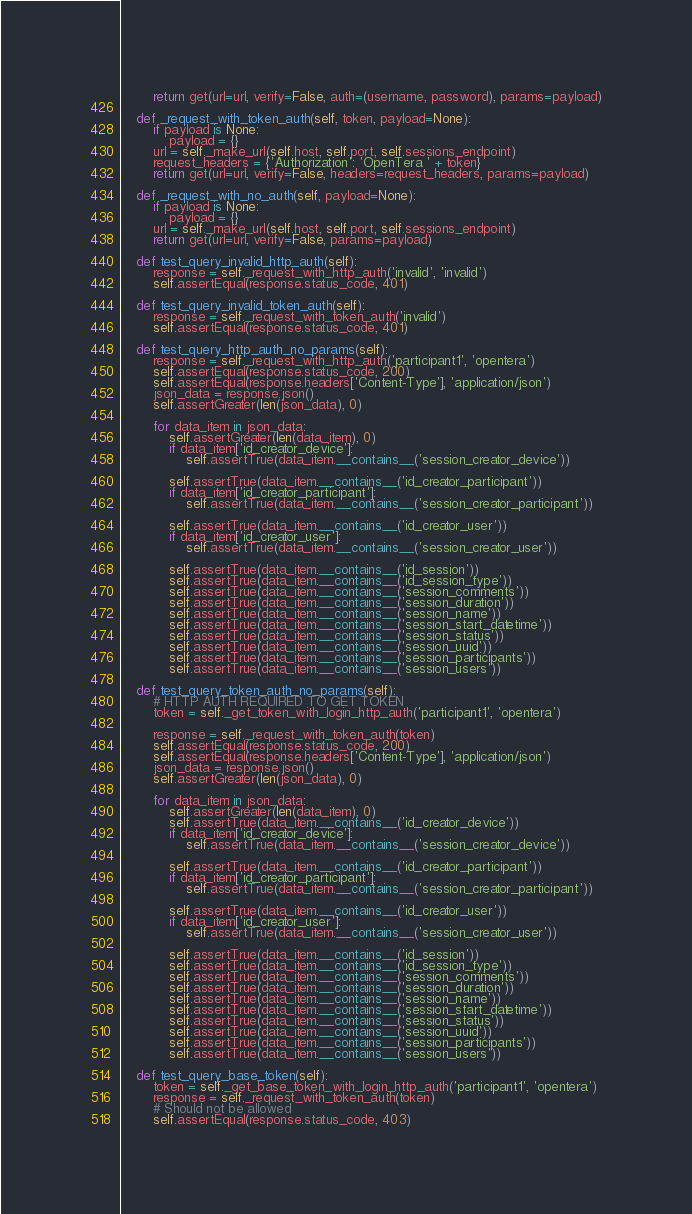<code> <loc_0><loc_0><loc_500><loc_500><_Python_>        return get(url=url, verify=False, auth=(username, password), params=payload)

    def _request_with_token_auth(self, token, payload=None):
        if payload is None:
            payload = {}
        url = self._make_url(self.host, self.port, self.sessions_endpoint)
        request_headers = {'Authorization': 'OpenTera ' + token}
        return get(url=url, verify=False, headers=request_headers, params=payload)

    def _request_with_no_auth(self, payload=None):
        if payload is None:
            payload = {}
        url = self._make_url(self.host, self.port, self.sessions_endpoint)
        return get(url=url, verify=False, params=payload)

    def test_query_invalid_http_auth(self):
        response = self._request_with_http_auth('invalid', 'invalid')
        self.assertEqual(response.status_code, 401)

    def test_query_invalid_token_auth(self):
        response = self._request_with_token_auth('invalid')
        self.assertEqual(response.status_code, 401)

    def test_query_http_auth_no_params(self):
        response = self._request_with_http_auth('participant1', 'opentera')
        self.assertEqual(response.status_code, 200)
        self.assertEqual(response.headers['Content-Type'], 'application/json')
        json_data = response.json()
        self.assertGreater(len(json_data), 0)

        for data_item in json_data:
            self.assertGreater(len(data_item), 0)
            if data_item['id_creator_device']:
                self.assertTrue(data_item.__contains__('session_creator_device'))

            self.assertTrue(data_item.__contains__('id_creator_participant'))
            if data_item['id_creator_participant']:
                self.assertTrue(data_item.__contains__('session_creator_participant'))

            self.assertTrue(data_item.__contains__('id_creator_user'))
            if data_item['id_creator_user']:
                self.assertTrue(data_item.__contains__('session_creator_user'))

            self.assertTrue(data_item.__contains__('id_session'))
            self.assertTrue(data_item.__contains__('id_session_type'))
            self.assertTrue(data_item.__contains__('session_comments'))
            self.assertTrue(data_item.__contains__('session_duration'))
            self.assertTrue(data_item.__contains__('session_name'))
            self.assertTrue(data_item.__contains__('session_start_datetime'))
            self.assertTrue(data_item.__contains__('session_status'))
            self.assertTrue(data_item.__contains__('session_uuid'))
            self.assertTrue(data_item.__contains__('session_participants'))
            self.assertTrue(data_item.__contains__('session_users'))

    def test_query_token_auth_no_params(self):
        # HTTP AUTH REQUIRED TO GET TOKEN
        token = self._get_token_with_login_http_auth('participant1', 'opentera')

        response = self._request_with_token_auth(token)
        self.assertEqual(response.status_code, 200)
        self.assertEqual(response.headers['Content-Type'], 'application/json')
        json_data = response.json()
        self.assertGreater(len(json_data), 0)

        for data_item in json_data:
            self.assertGreater(len(data_item), 0)
            self.assertTrue(data_item.__contains__('id_creator_device'))
            if data_item['id_creator_device']:
                self.assertTrue(data_item.__contains__('session_creator_device'))

            self.assertTrue(data_item.__contains__('id_creator_participant'))
            if data_item['id_creator_participant']:
                self.assertTrue(data_item.__contains__('session_creator_participant'))

            self.assertTrue(data_item.__contains__('id_creator_user'))
            if data_item['id_creator_user']:
                self.assertTrue(data_item.__contains__('session_creator_user'))

            self.assertTrue(data_item.__contains__('id_session'))
            self.assertTrue(data_item.__contains__('id_session_type'))
            self.assertTrue(data_item.__contains__('session_comments'))
            self.assertTrue(data_item.__contains__('session_duration'))
            self.assertTrue(data_item.__contains__('session_name'))
            self.assertTrue(data_item.__contains__('session_start_datetime'))
            self.assertTrue(data_item.__contains__('session_status'))
            self.assertTrue(data_item.__contains__('session_uuid'))
            self.assertTrue(data_item.__contains__('session_participants'))
            self.assertTrue(data_item.__contains__('session_users'))

    def test_query_base_token(self):
        token = self._get_base_token_with_login_http_auth('participant1', 'opentera')
        response = self._request_with_token_auth(token)
        # Should not be allowed
        self.assertEqual(response.status_code, 403)
</code> 